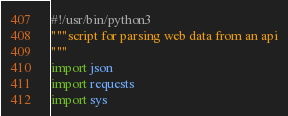<code> <loc_0><loc_0><loc_500><loc_500><_Python_>#!/usr/bin/python3
"""script for parsing web data from an api
"""
import json
import requests
import sys

</code> 